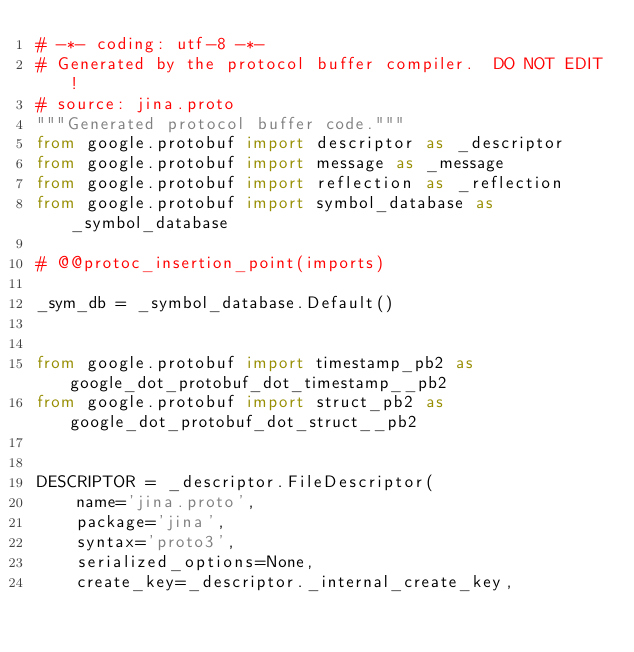<code> <loc_0><loc_0><loc_500><loc_500><_Python_># -*- coding: utf-8 -*-
# Generated by the protocol buffer compiler.  DO NOT EDIT!
# source: jina.proto
"""Generated protocol buffer code."""
from google.protobuf import descriptor as _descriptor
from google.protobuf import message as _message
from google.protobuf import reflection as _reflection
from google.protobuf import symbol_database as _symbol_database

# @@protoc_insertion_point(imports)

_sym_db = _symbol_database.Default()


from google.protobuf import timestamp_pb2 as google_dot_protobuf_dot_timestamp__pb2
from google.protobuf import struct_pb2 as google_dot_protobuf_dot_struct__pb2


DESCRIPTOR = _descriptor.FileDescriptor(
    name='jina.proto',
    package='jina',
    syntax='proto3',
    serialized_options=None,
    create_key=_descriptor._internal_create_key,</code> 